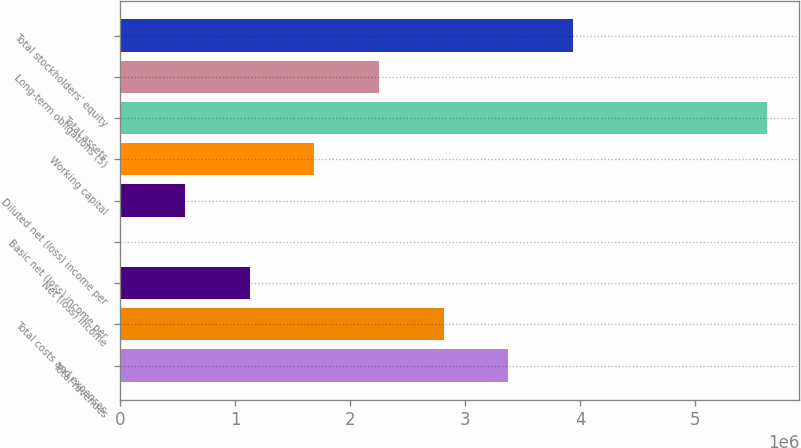Convert chart to OTSL. <chart><loc_0><loc_0><loc_500><loc_500><bar_chart><fcel>Total revenues<fcel>Total costs and expenses<fcel>Net (loss) income<fcel>Basic net (loss) income per<fcel>Diluted net (loss) income per<fcel>Working capital<fcel>Total assets<fcel>Long-term obligations (5)<fcel>Total stockholders' equity<nl><fcel>3.3755e+06<fcel>2.81292e+06<fcel>1.12517e+06<fcel>0.24<fcel>562584<fcel>1.68775e+06<fcel>5.62583e+06<fcel>2.25033e+06<fcel>3.93808e+06<nl></chart> 